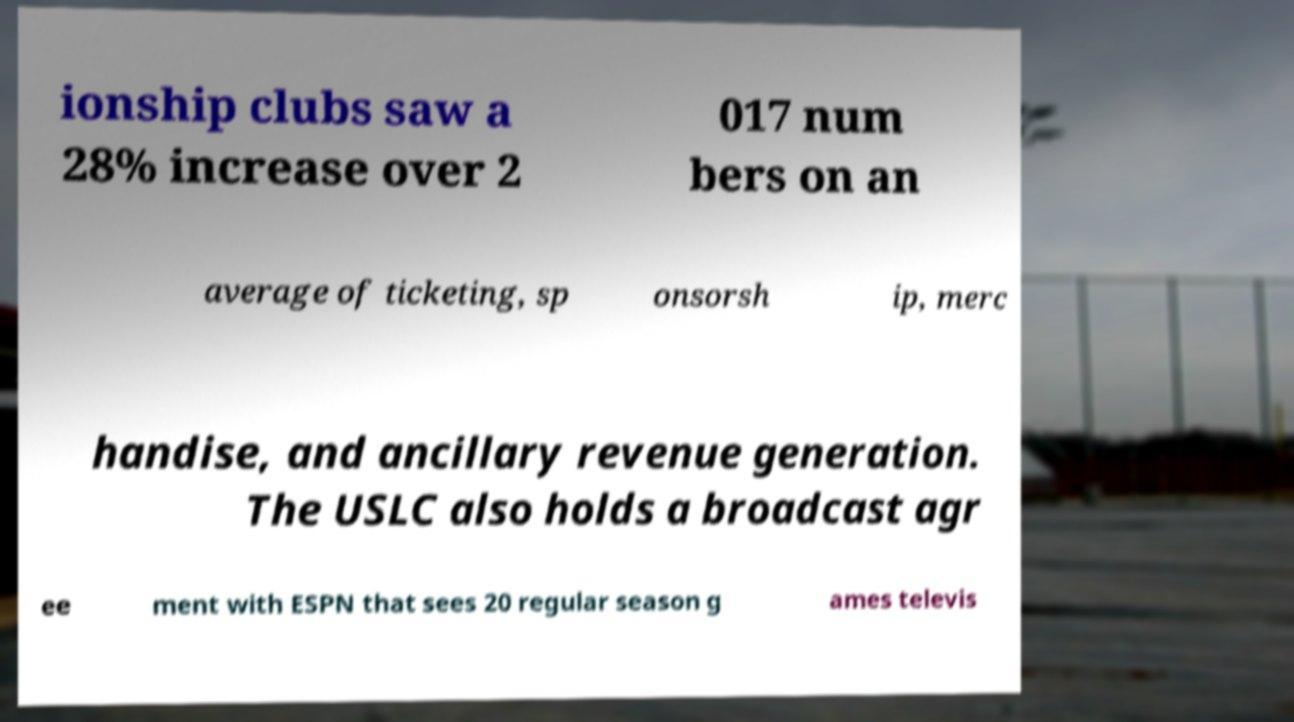I need the written content from this picture converted into text. Can you do that? ionship clubs saw a 28% increase over 2 017 num bers on an average of ticketing, sp onsorsh ip, merc handise, and ancillary revenue generation. The USLC also holds a broadcast agr ee ment with ESPN that sees 20 regular season g ames televis 